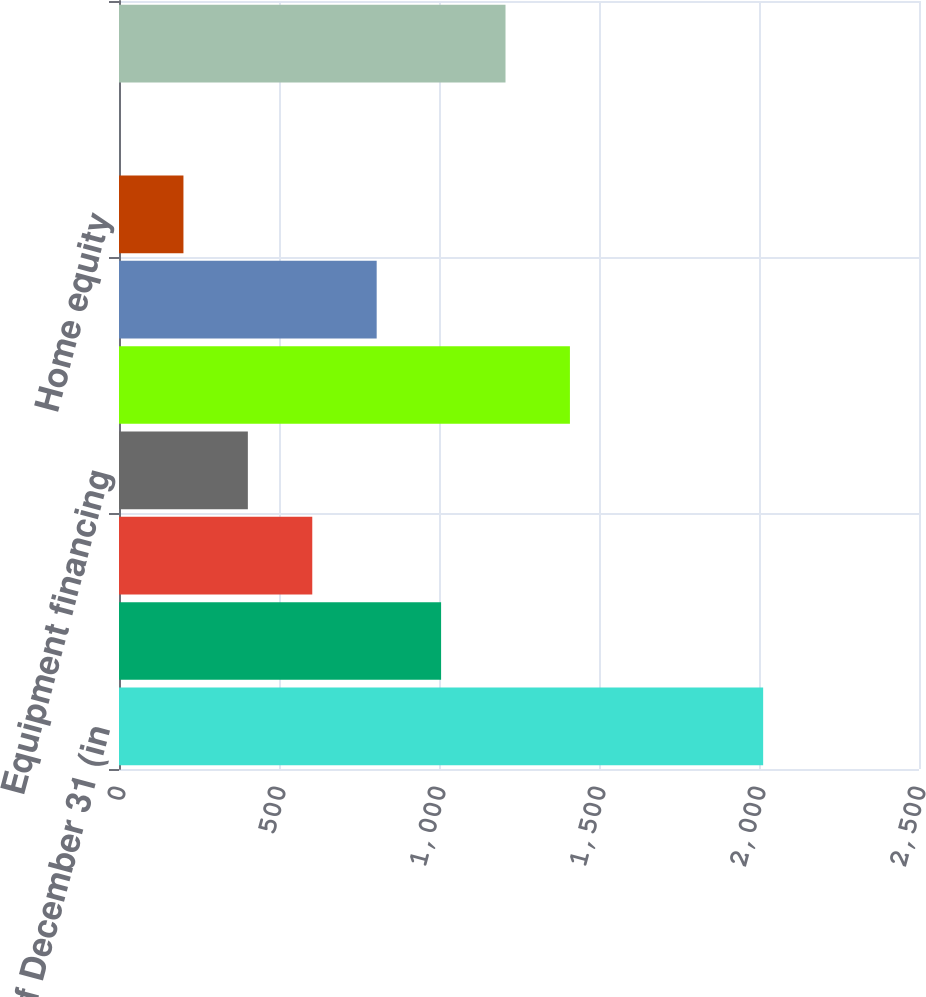Convert chart. <chart><loc_0><loc_0><loc_500><loc_500><bar_chart><fcel>As of December 31 (in<fcel>Commercial real estate<fcel>Commercial and industrial<fcel>Equipment financing<fcel>Total (1)<fcel>Residential mortgage<fcel>Home equity<fcel>Other consumer<fcel>Total<nl><fcel>2013<fcel>1006.55<fcel>603.97<fcel>402.68<fcel>1409.13<fcel>805.26<fcel>201.39<fcel>0.1<fcel>1207.84<nl></chart> 